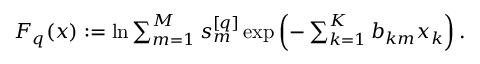Convert formula to latex. <formula><loc_0><loc_0><loc_500><loc_500>\begin{array} { r } { F _ { q } ( x ) \colon = \ln \sum _ { m = 1 } ^ { M } s _ { m } ^ { [ q ] } \exp \left ( - \sum _ { k = 1 } ^ { K } b _ { k m } x _ { k } \right ) . } \end{array}</formula> 